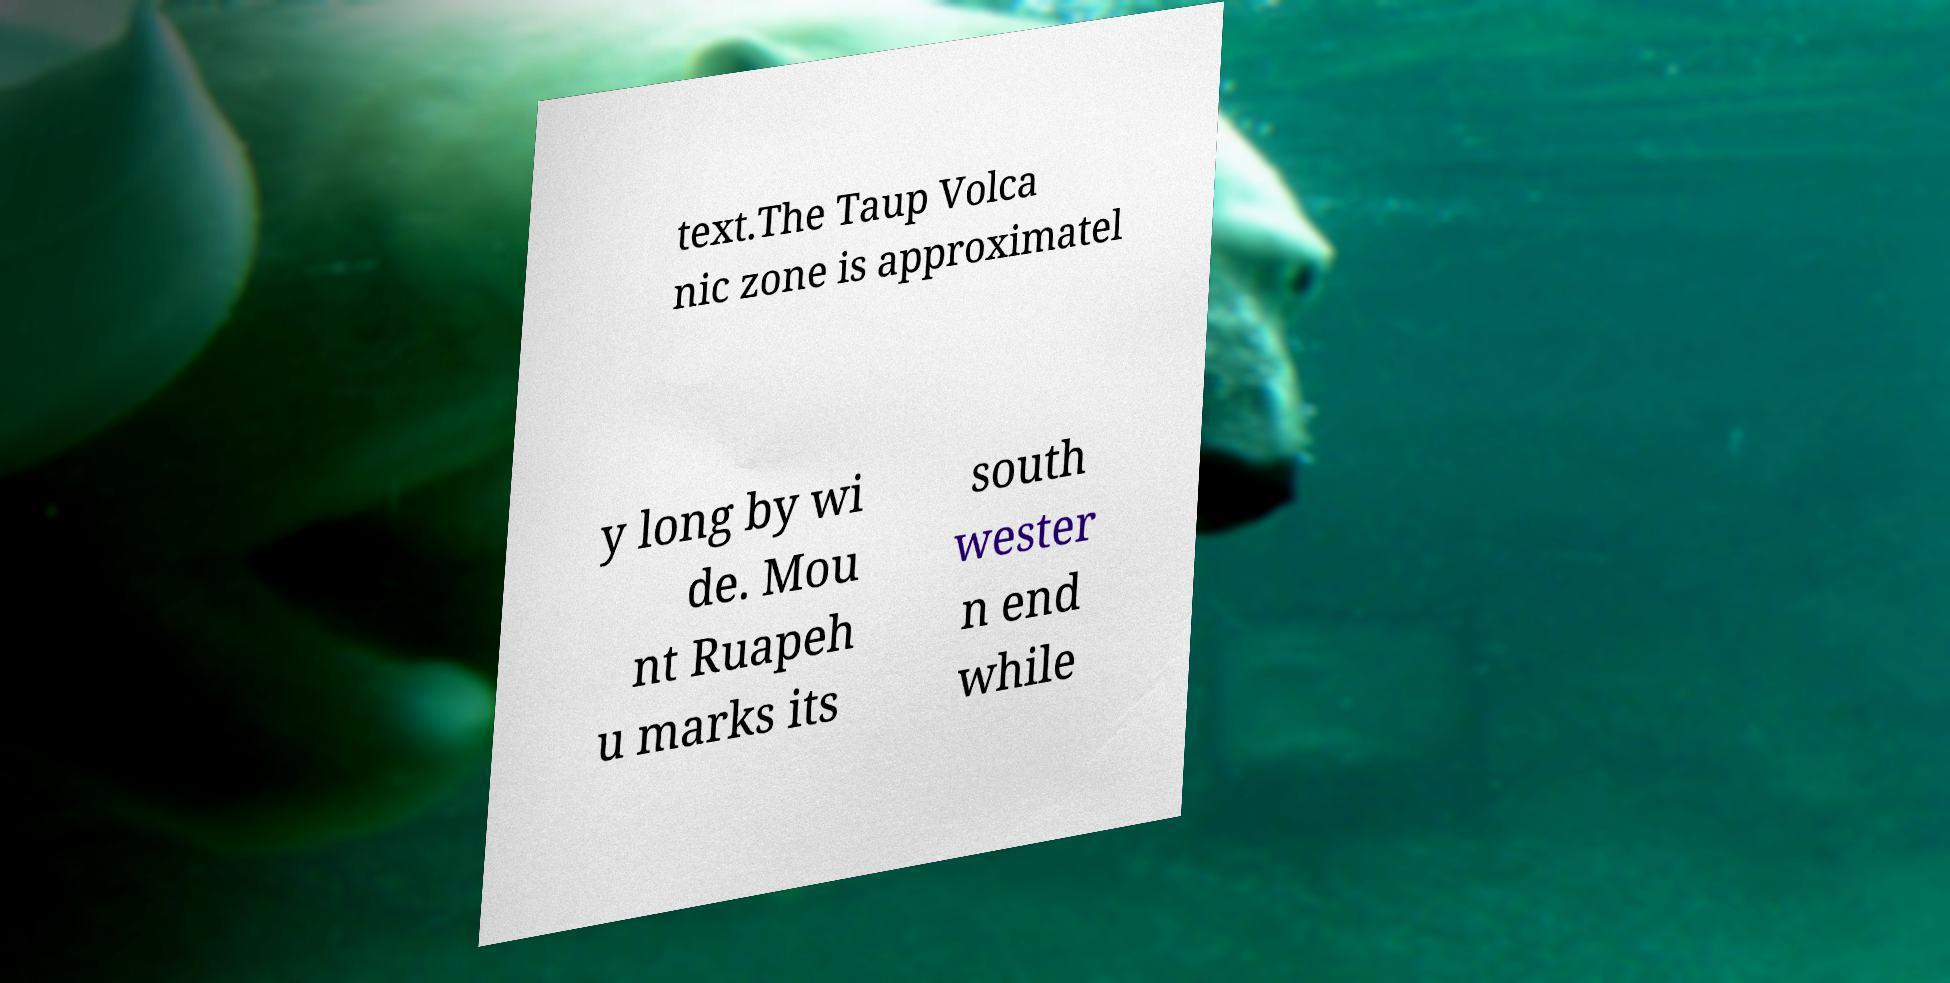What messages or text are displayed in this image? I need them in a readable, typed format. text.The Taup Volca nic zone is approximatel y long by wi de. Mou nt Ruapeh u marks its south wester n end while 